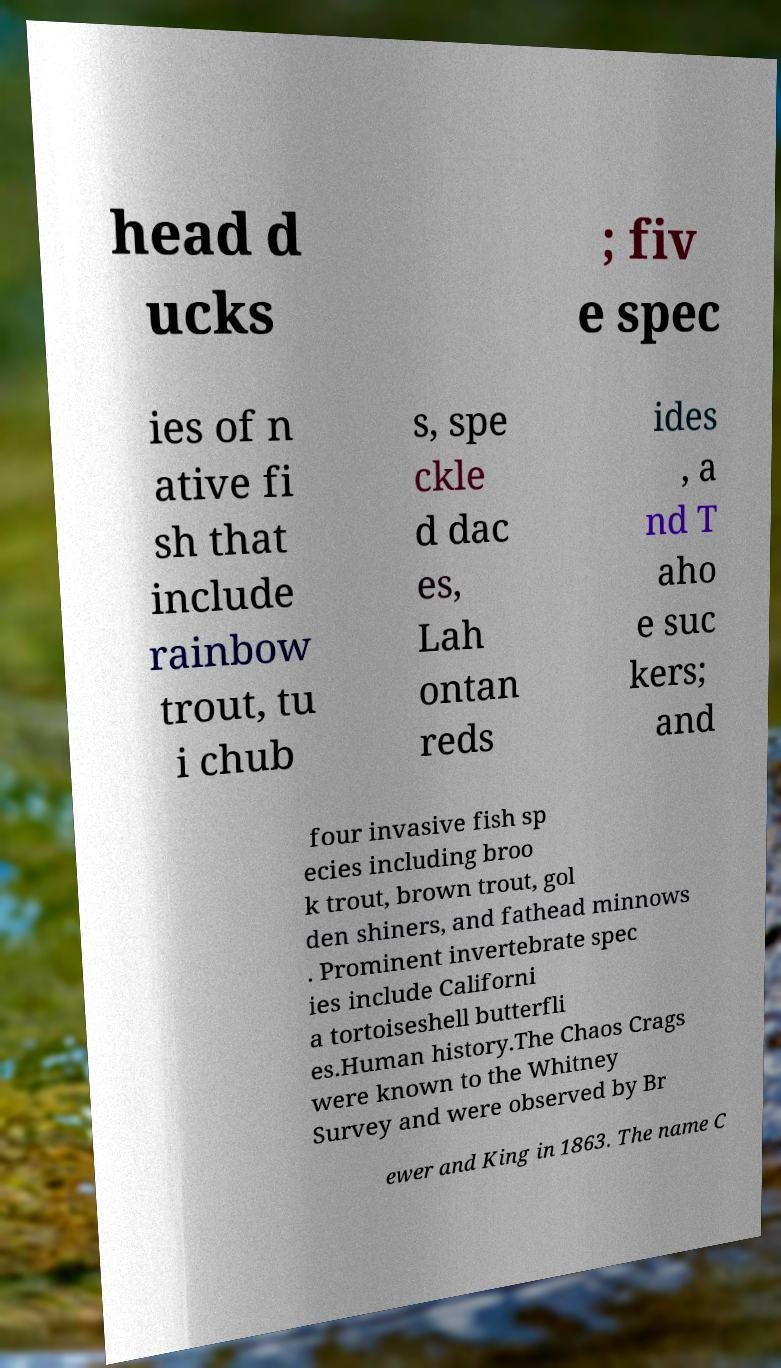There's text embedded in this image that I need extracted. Can you transcribe it verbatim? head d ucks ; fiv e spec ies of n ative fi sh that include rainbow trout, tu i chub s, spe ckle d dac es, Lah ontan reds ides , a nd T aho e suc kers; and four invasive fish sp ecies including broo k trout, brown trout, gol den shiners, and fathead minnows . Prominent invertebrate spec ies include Californi a tortoiseshell butterfli es.Human history.The Chaos Crags were known to the Whitney Survey and were observed by Br ewer and King in 1863. The name C 